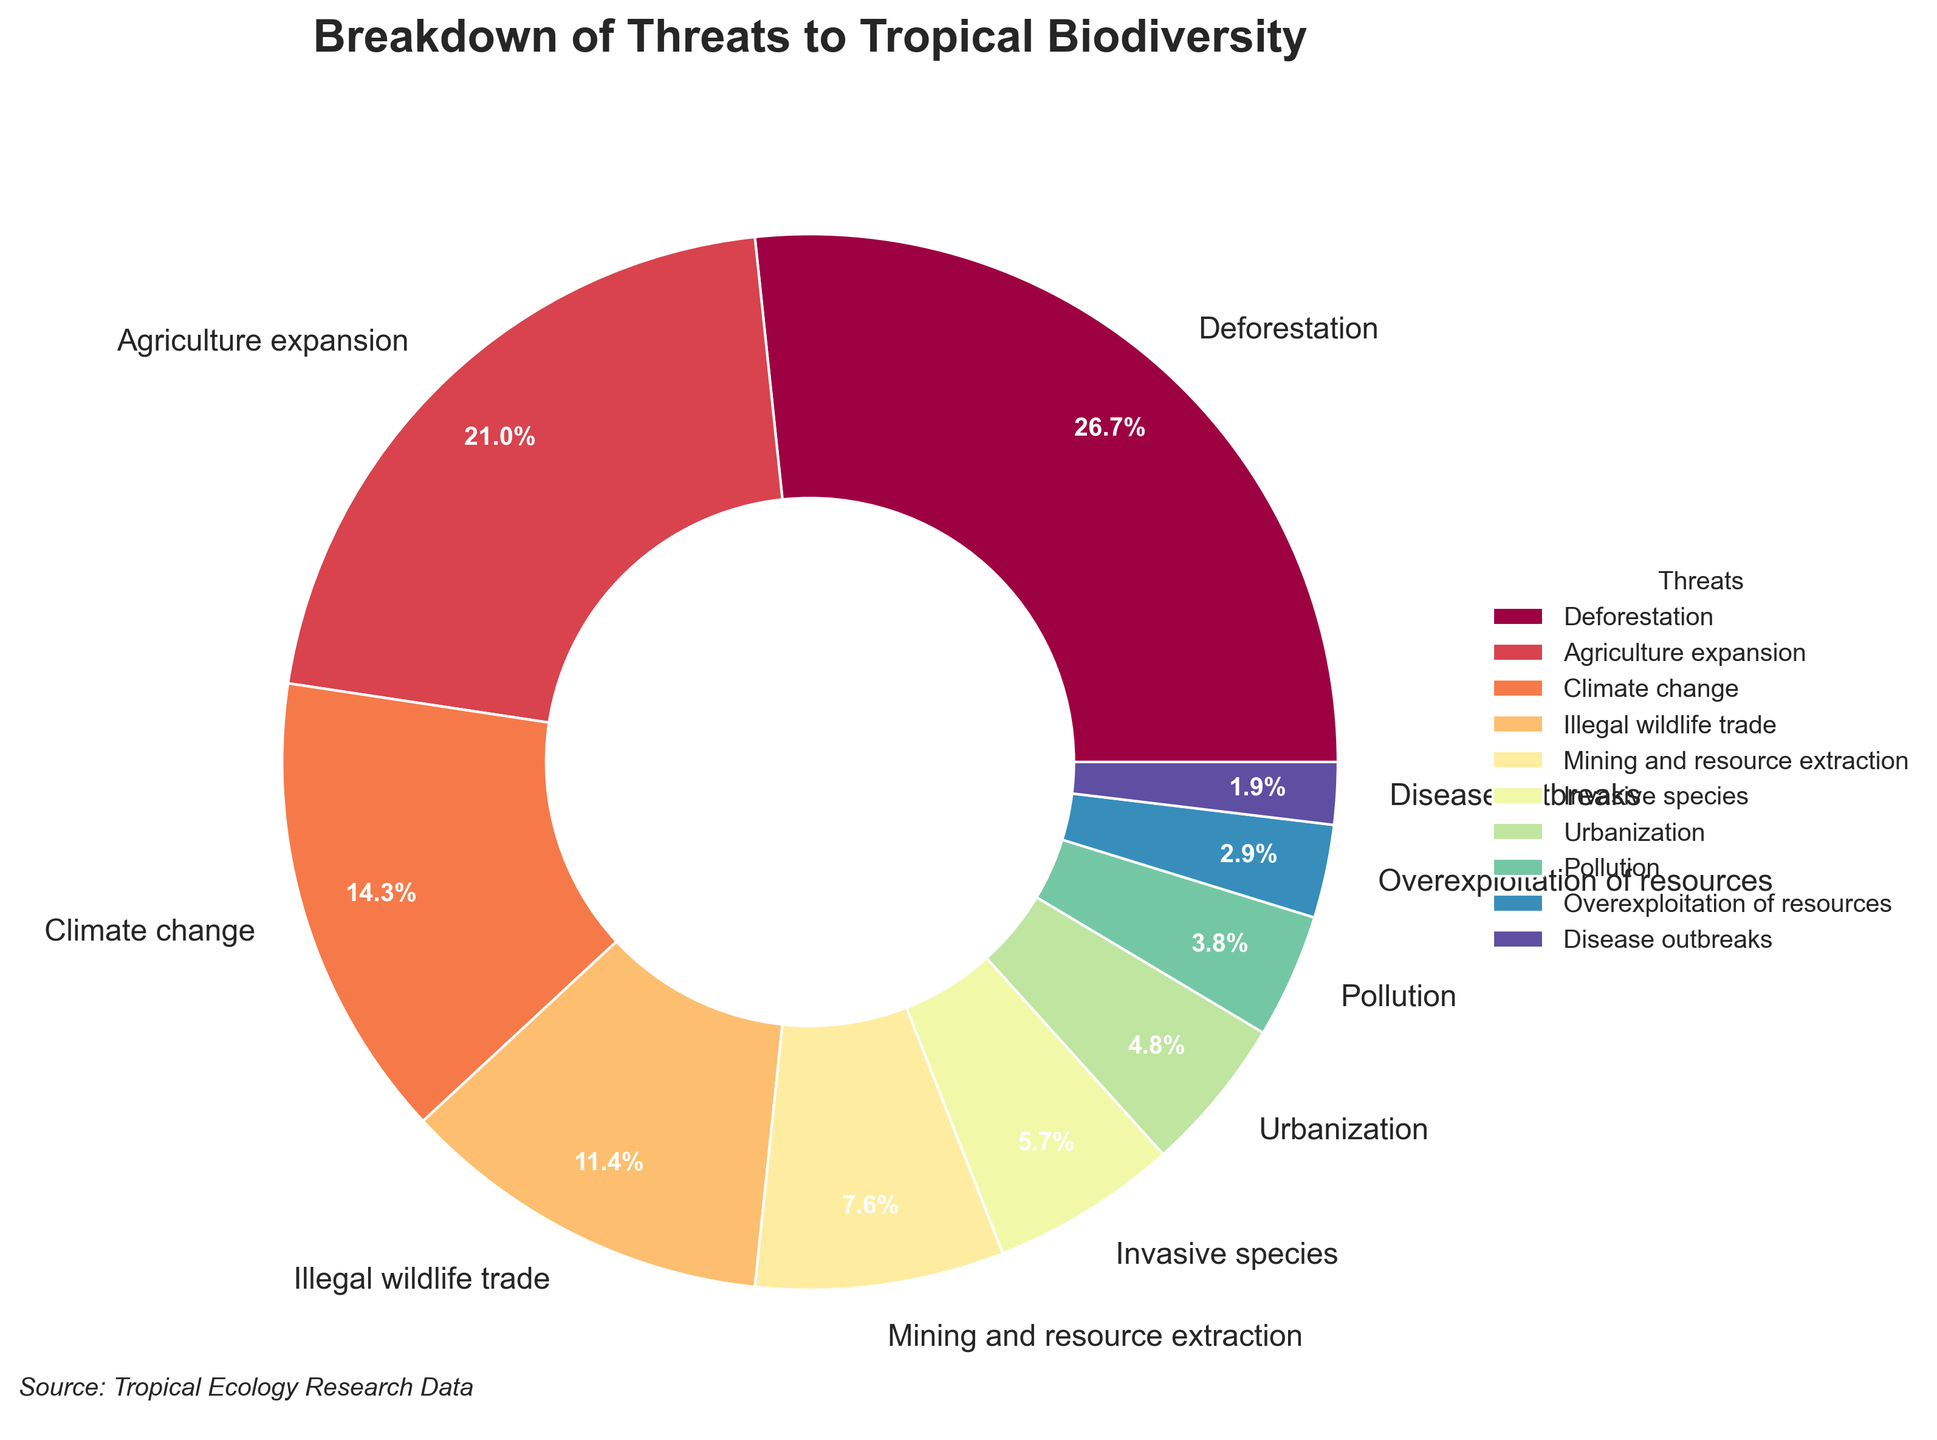Which threat accounts for the highest percentage of threats to tropical biodiversity? The threat with the highest percentage can be determined by identifying the category with the largest slice in the pie chart.
Answer: Deforestation How much larger is the percentage of Agriculture expansion compared to Illegal wildlife trade? First, find the percentages for both Agriculture expansion (22%) and Illegal wildlife trade (12%). Subtract the smaller percentage from the larger percentage: 22% - 12% = 10%.
Answer: 10% What is the combined percentage of threats from Pollution and Overexploitation of resources? Locate the percentages for Pollution (4%) and Overexploitation of resources (3%). Add these two values together: 4% + 3% = 7%.
Answer: 7% Which threat contributes less to tropical biodiversity threats, Urbanization or Disease outbreaks? Compare the percentages for Urbanization (5%) and Disease outbreaks (2%). Since 2% is less than 5%, Disease outbreaks contributes less.
Answer: Disease outbreaks What is the difference in percentage between the highest and the lowest threats to tropical biodiversity? Identify the highest percentage (Deforestation, 28%) and the lowest percentage (Disease outbreaks, 2%). Subtract the lowest percentage from the highest: 28% - 2% = 26%.
Answer: 26% If you combine the percentages of Climate change, Illegal wildlife trade, and Mining and resource extraction, what is the total percentage? Sum the percentages of Climate change (15%), Illegal wildlife trade (12%), and Mining and resource extraction (8%): 15% + 12% + 8% = 35%.
Answer: 35% What is the percentage difference between threats from Invasive species and Mining and resource extraction? Find the percentages for both Invasive species (6%) and Mining and resource extraction (8%). Subtract the smaller percentage from the larger: 8% - 6% = 2%.
Answer: 2% How does the percentage of threats from Urbanization compare to that from Overexploitation of resources? Compare the percentages for Urbanization (5%) and Overexploitation of resources (3%). Since 5% is greater than 3%, Urbanization has a higher percentage of threats.
Answer: Urbanization higher Which visual attribute indicates the severity of each threat in the pie chart? In the pie chart, the size of each wedge visually represents the severity of each threat, with larger wedges indicating higher percentages.
Answer: Size of wedges What is the combined percentage of all threats listed? Sum all percentages provided: 28% + 22% + 15% + 12% + 8% + 6% + 5% + 4% + 3% + 2% = 105%. This discrepancy might indicate a rounding error or data issue.
Answer: 105% 